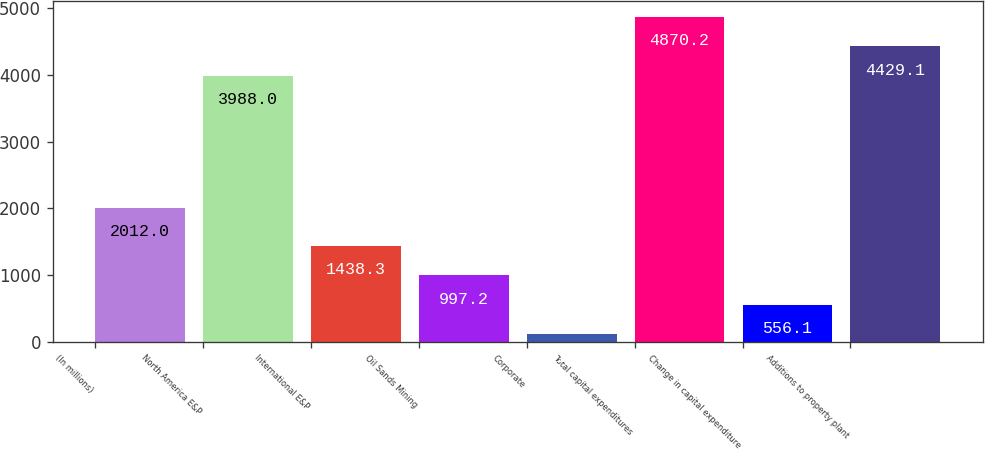<chart> <loc_0><loc_0><loc_500><loc_500><bar_chart><fcel>(In millions)<fcel>North America E&P<fcel>International E&P<fcel>Oil Sands Mining<fcel>Corporate<fcel>Total capital expenditures<fcel>Change in capital expenditure<fcel>Additions to property plant<nl><fcel>2012<fcel>3988<fcel>1438.3<fcel>997.2<fcel>115<fcel>4870.2<fcel>556.1<fcel>4429.1<nl></chart> 